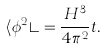Convert formula to latex. <formula><loc_0><loc_0><loc_500><loc_500>\langle \phi ^ { 2 } \rangle = \frac { H ^ { 3 } } { 4 \pi ^ { 2 } } t .</formula> 